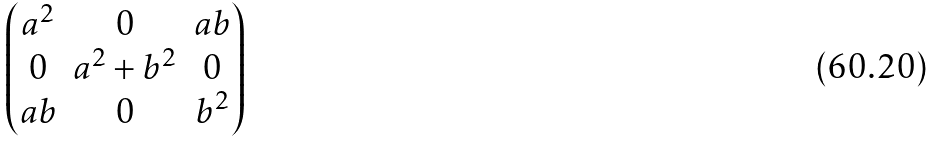<formula> <loc_0><loc_0><loc_500><loc_500>\begin{pmatrix} a ^ { 2 } & 0 & a b \\ 0 & a ^ { 2 } + b ^ { 2 } & 0 \\ a b & 0 & b ^ { 2 } \end{pmatrix}</formula> 